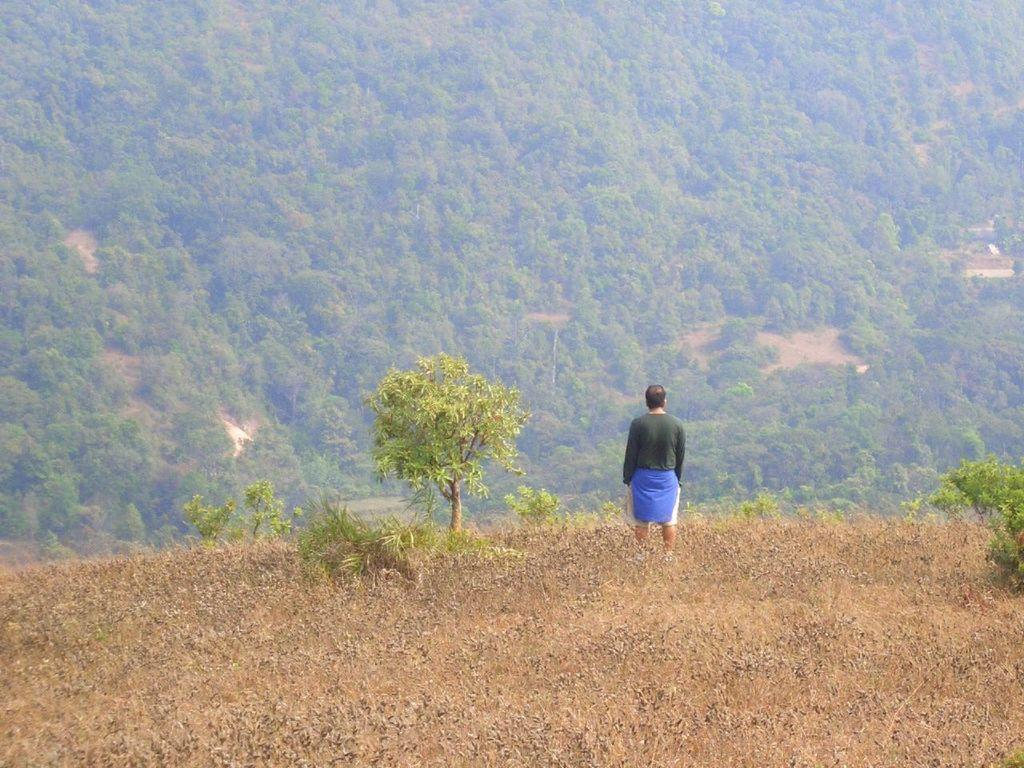What is the main subject of the image? There is a person standing in the image. What is the surface the person is standing on? The person is standing on a dry grass surface. What can be seen in front of the person? There are plants, trees, and mountains in front of the person. What color is the crayon the person is holding in the image? There is no crayon present in the image. What type of wall is behind the person in the image? There is no wall visible in the image. 